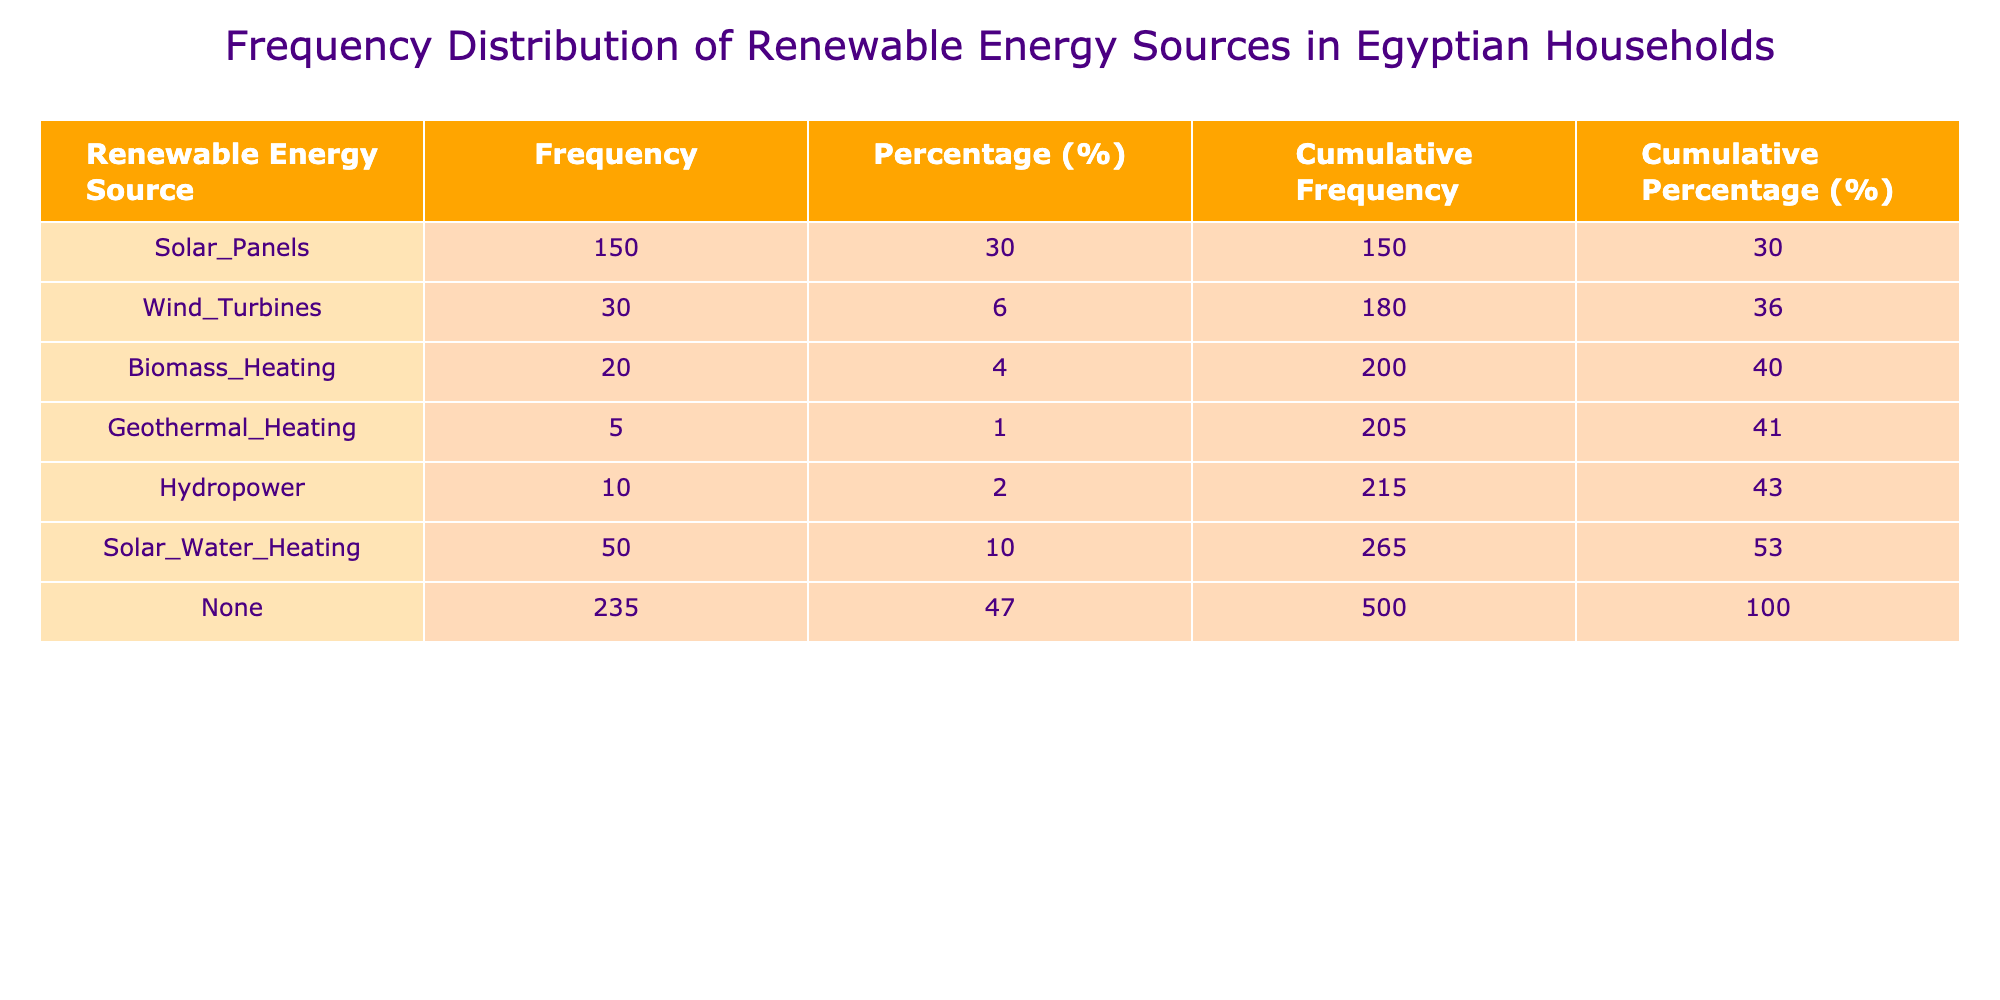What is the frequency of Solar Panels used in Egyptian households? According to the table, the frequency of Solar Panels is directly listed as 150.
Answer: 150 What percentage of households use Wind Turbines? The frequency of Wind Turbines is 30. The total frequency is 300 (150 + 30 + 20 + 5 + 10 + 50 + 235). To find the percentage, calculate (30/300) * 100 = 10%.
Answer: 10% How many more households use Solar Panels than Biomass Heating? The frequency of Solar Panels is 150, and for Biomass Heating, it is 20. The difference is calculated by subtracting the frequency of Biomass Heating from that of Solar Panels: 150 - 20 = 130.
Answer: 130 Is the frequency of households using Hydropower greater than that using Geothermal Heating? The frequency of Hydropower is 10, while for Geothermal Heating, it is 5. Since 10 is greater than 5, the statement is true.
Answer: Yes What is the cumulative frequency of households using Solar Water Heating and none? The frequency for Solar Water Heating is 50, and for none it is 235. The cumulative frequency is the sum: 50 + 235 = 285.
Answer: 285 What is the total number of households using Renewable Energy Sources? Summing up all the frequencies gives: 150 (Solar Panels) + 30 (Wind Turbines) + 20 (Biomass Heating) + 5 (Geothermal Heating) + 10 (Hydropower) + 50 (Solar Water Heating) + 235 (None) = 500.
Answer: 500 What is the cumulative percentage for households using Biomass Heating? The cumulative frequency for Biomass Heating is 200 (150 + 30 + 20). The total frequency is 300. Calculating the cumulative percentage gives (200/500) * 100 = 40%.
Answer: 40% How many households do not use any form of renewable energy? The table lists the frequency of 'None' as 235. This directly answers the question about the number of households not using any renewable source.
Answer: 235 What percentage of households use any type of renewable energy source at all? Adding up all the renewable sources gives 150 + 30 + 20 + 5 + 10 + 50 = 265. The total number of households is 500. To get the percentage, (265/500) * 100 = 53%.
Answer: 53% 